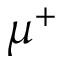Convert formula to latex. <formula><loc_0><loc_0><loc_500><loc_500>\mu ^ { + }</formula> 